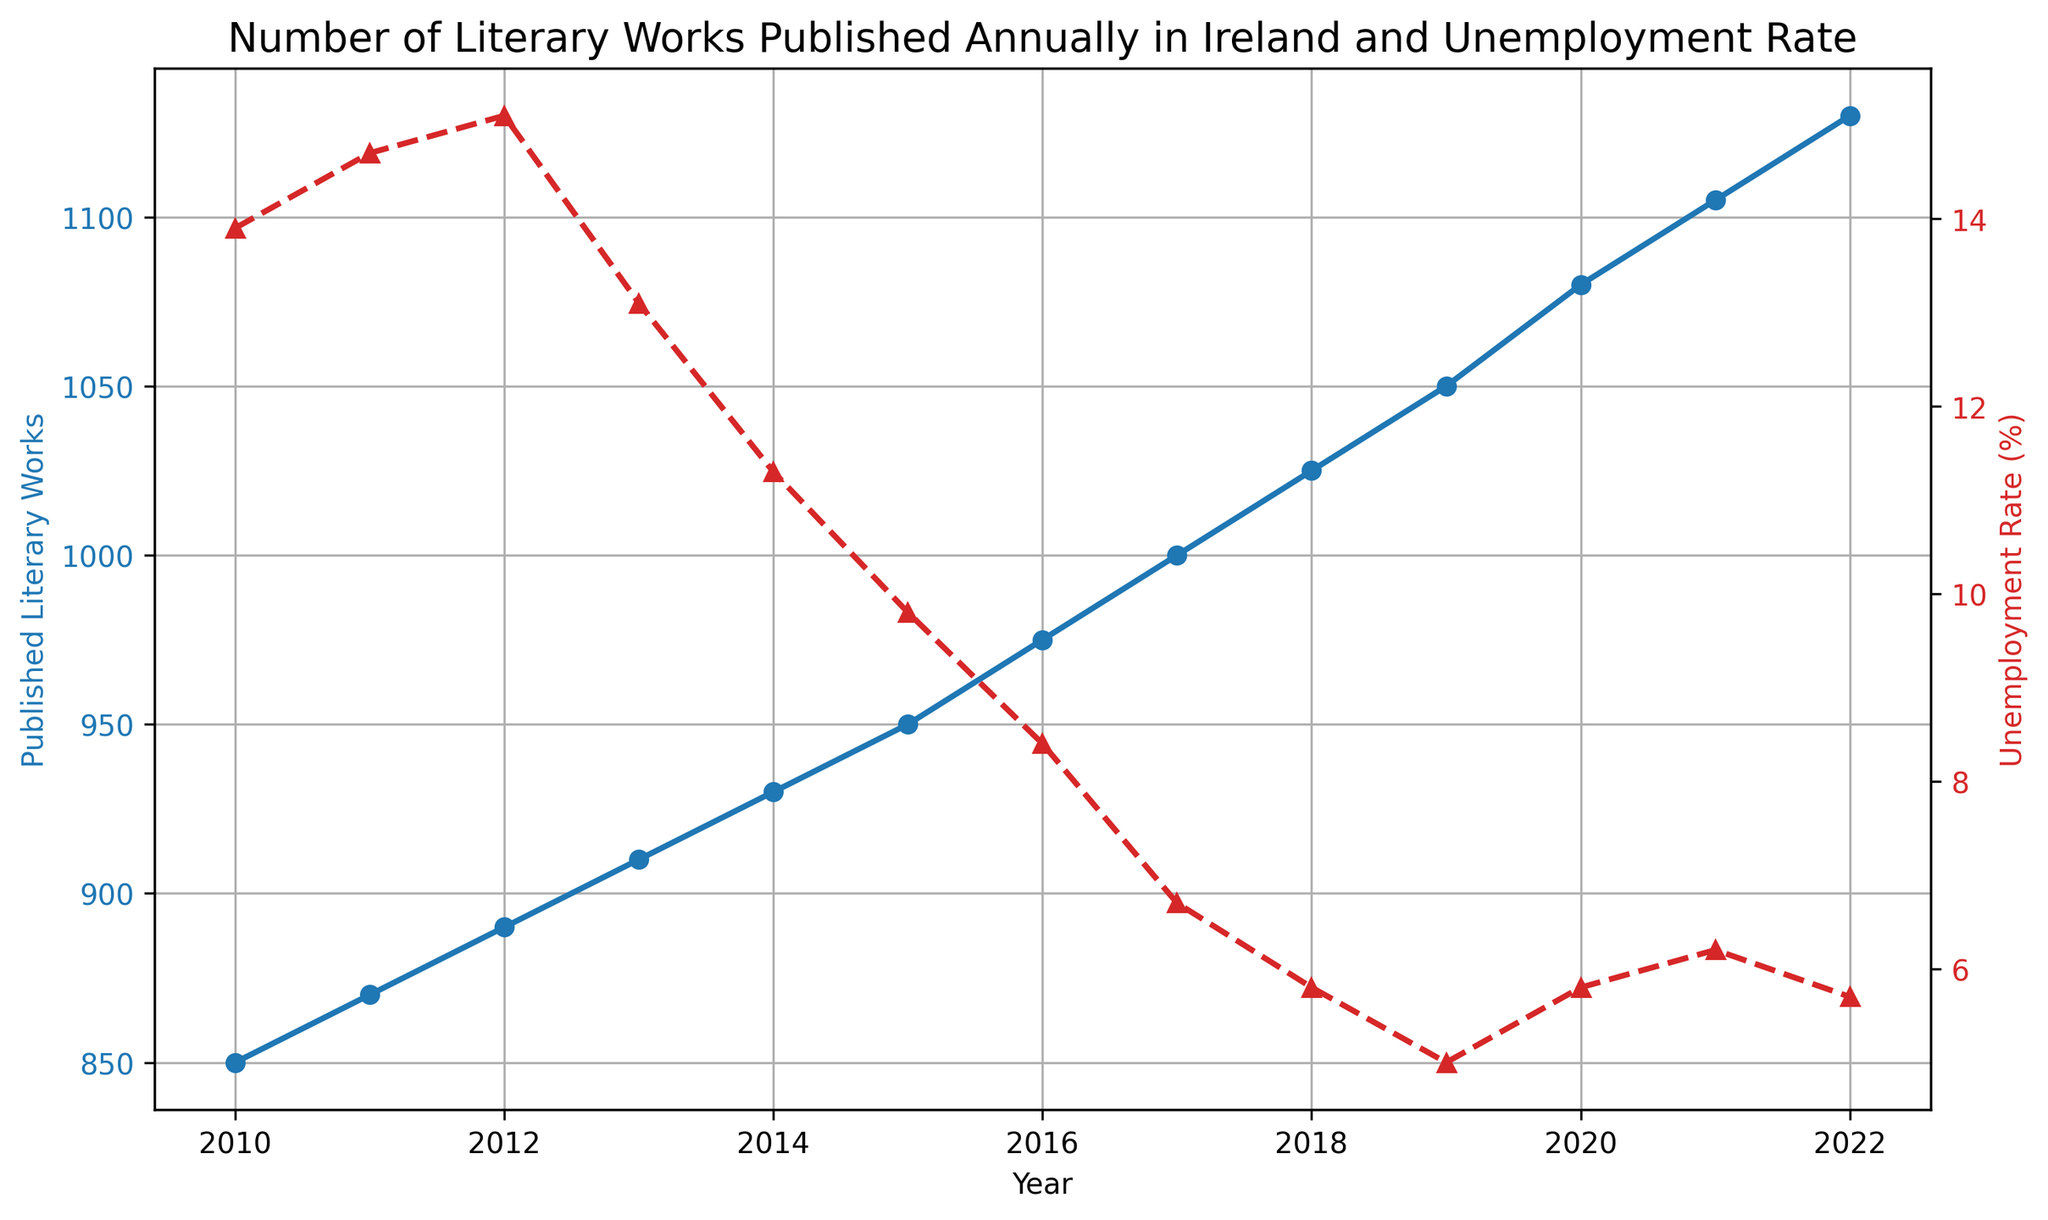What is the trend in the number of published literary works from 2010 to 2022? To determine the trend, observe the plot for the 'Published Literary Works'. The number of publications consistently increases from 850 in 2010 to 1130 in 2022.
Answer: Increasing How did the unemployment rate change from 2010 to 2022? To determine the change, observe the plot for the 'Unemployment Rate'. It starts at 13.9% in 2010, peaks at 15.1% in 2012, and then generally decreases, ending at 5.7% in 2022.
Answer: Decreasing In which year was the highest unemployment rate observed, and what was the value? Identify the peak of the 'Unemployment Rate' plot. The highest value, 15.1%, is observed in 2012.
Answer: 2012, 15.1% Between 2010 and 2022, which year showed the largest increase in the number of published literary works from the previous year? Check the differences in the 'Published Literary Works' plot. The largest increase, from 975 to 1000 works, occurs between 2016 and 2017 (an increase of 25 works).
Answer: 2017 Is there any visible correlation between the number of published literary works and the unemployment rate? To determine correlation, observe the relationship between the two plots. As the unemployment rate decreases, the number of published works generally increases, suggesting a possible inverse correlation.
Answer: Possible inverse correlation How did the number of published literary works and the unemployment rate change from 2012 to 2013? Observe the changes for both metrics between these years. The number of published literary works increased from 890 to 910, while the unemployment rate decreased from 15.1% to 13.1%.
Answer: Increase, Decrease What was the unemployment rate in 2015, and how many literary works were published in the same year? Refer to the corresponding points on both plots for the year 2015. The unemployment rate was 9.8% and 950 literary works were published.
Answer: 9.8%, 950 Which year had the smallest gap between the number of published literary works and the unemployment rate, and what were the values? Examine the distance between the two plots for each year. In 2020, the gap appears smaller with 1080 works and a 5.8% unemployment rate.
Answer: 2020, 1080, 5.8% Calculate the average number of literary works published per year between 2010 and 2022. Sum the total number of works published from 2010 to 2022 and divide by the number of years (13). Sum = 13665, so average = 13665 / 13 ≈ 1051.15
Answer: 1051.15 